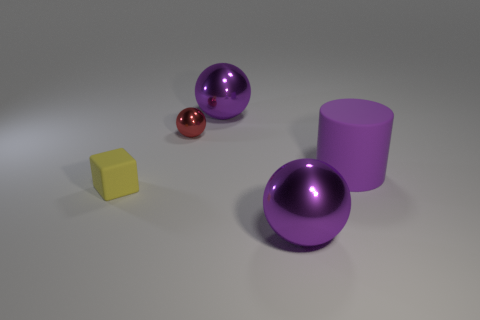Is there a large purple metal object right of the large purple rubber cylinder that is behind the yellow thing?
Your answer should be compact. No. What number of tiny things are metallic balls or objects?
Your answer should be very brief. 2. Is there a rubber cube of the same size as the red object?
Offer a very short reply. Yes. What number of metallic things are either yellow things or balls?
Provide a succinct answer. 3. How many gray matte balls are there?
Your answer should be compact. 0. Do the large purple thing that is behind the red ball and the large purple object that is in front of the tiny yellow thing have the same material?
Keep it short and to the point. Yes. There is a cube that is made of the same material as the big purple cylinder; what is its size?
Ensure brevity in your answer.  Small. There is a big thing that is behind the red metal object; what shape is it?
Make the answer very short. Sphere. There is a big shiny thing in front of the small yellow object; is its color the same as the large ball behind the big matte thing?
Your response must be concise. Yes. Are there any big purple rubber cylinders?
Your response must be concise. Yes. 